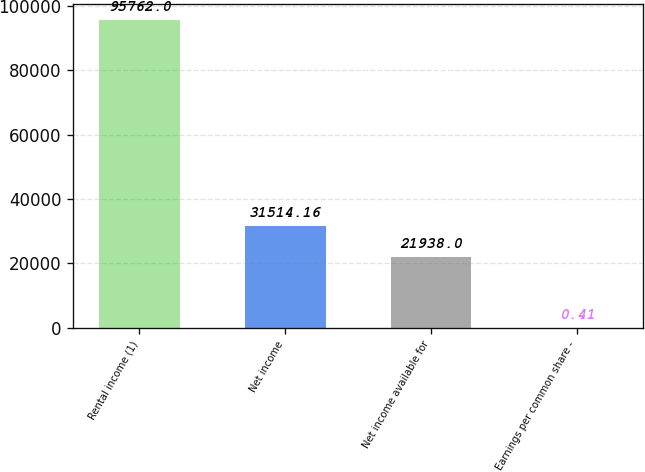Convert chart to OTSL. <chart><loc_0><loc_0><loc_500><loc_500><bar_chart><fcel>Rental income (1)<fcel>Net income<fcel>Net income available for<fcel>Earnings per common share -<nl><fcel>95762<fcel>31514.2<fcel>21938<fcel>0.41<nl></chart> 